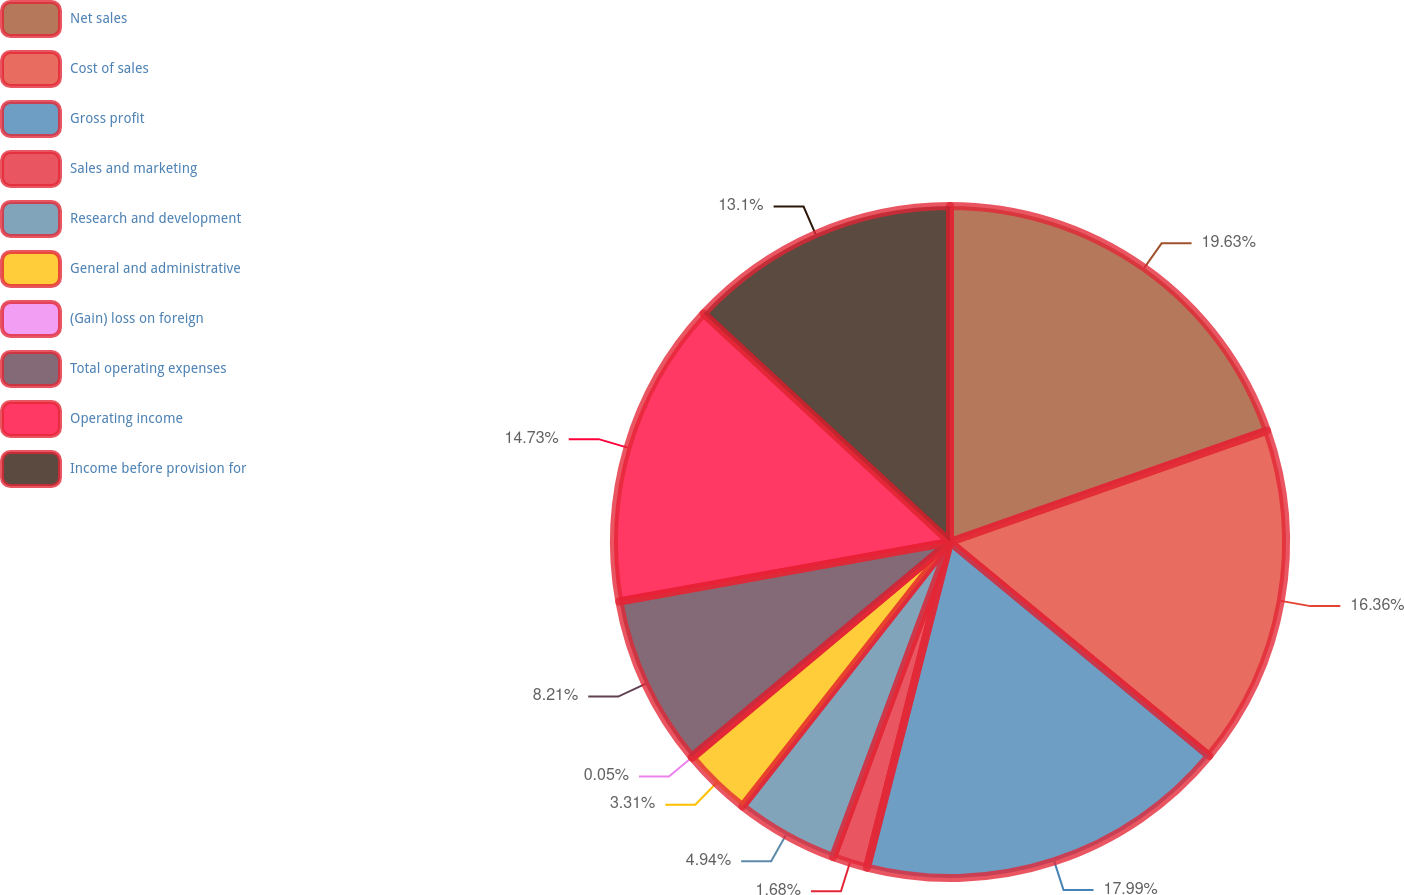Convert chart to OTSL. <chart><loc_0><loc_0><loc_500><loc_500><pie_chart><fcel>Net sales<fcel>Cost of sales<fcel>Gross profit<fcel>Sales and marketing<fcel>Research and development<fcel>General and administrative<fcel>(Gain) loss on foreign<fcel>Total operating expenses<fcel>Operating income<fcel>Income before provision for<nl><fcel>19.62%<fcel>16.36%<fcel>17.99%<fcel>1.68%<fcel>4.94%<fcel>3.31%<fcel>0.05%<fcel>8.21%<fcel>14.73%<fcel>13.1%<nl></chart> 